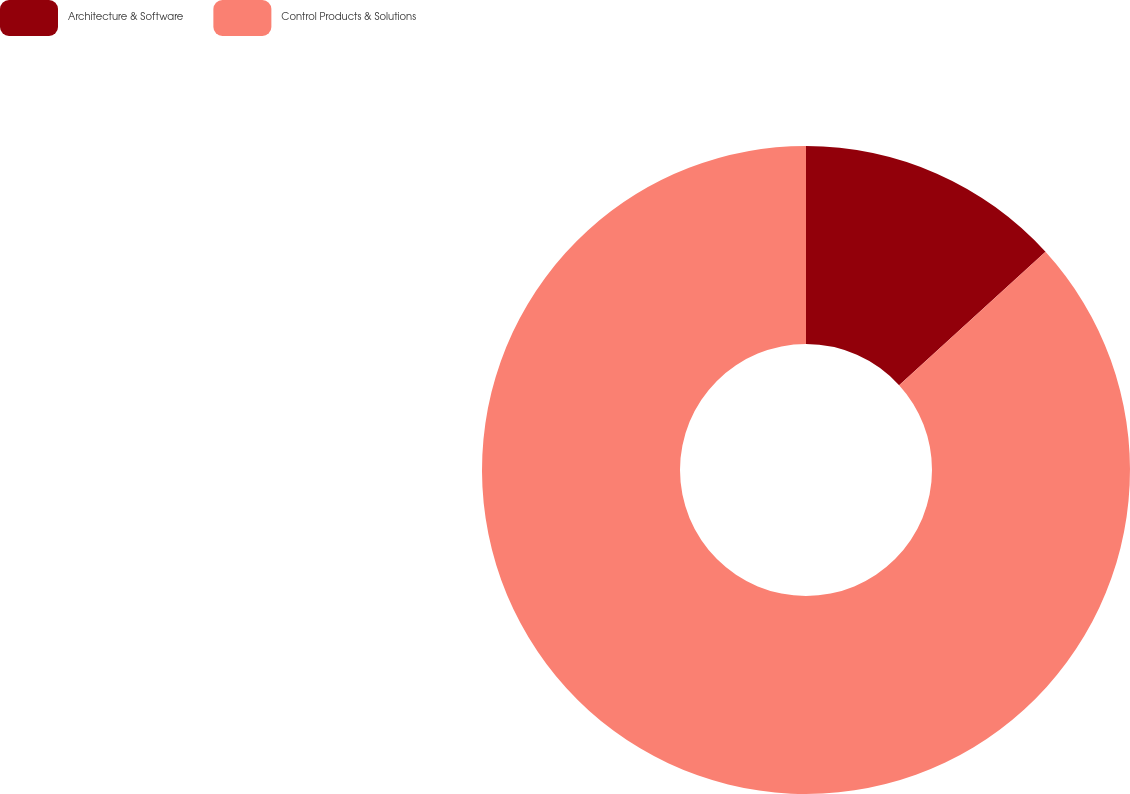Convert chart to OTSL. <chart><loc_0><loc_0><loc_500><loc_500><pie_chart><fcel>Architecture & Software<fcel>Control Products & Solutions<nl><fcel>13.24%<fcel>86.76%<nl></chart> 